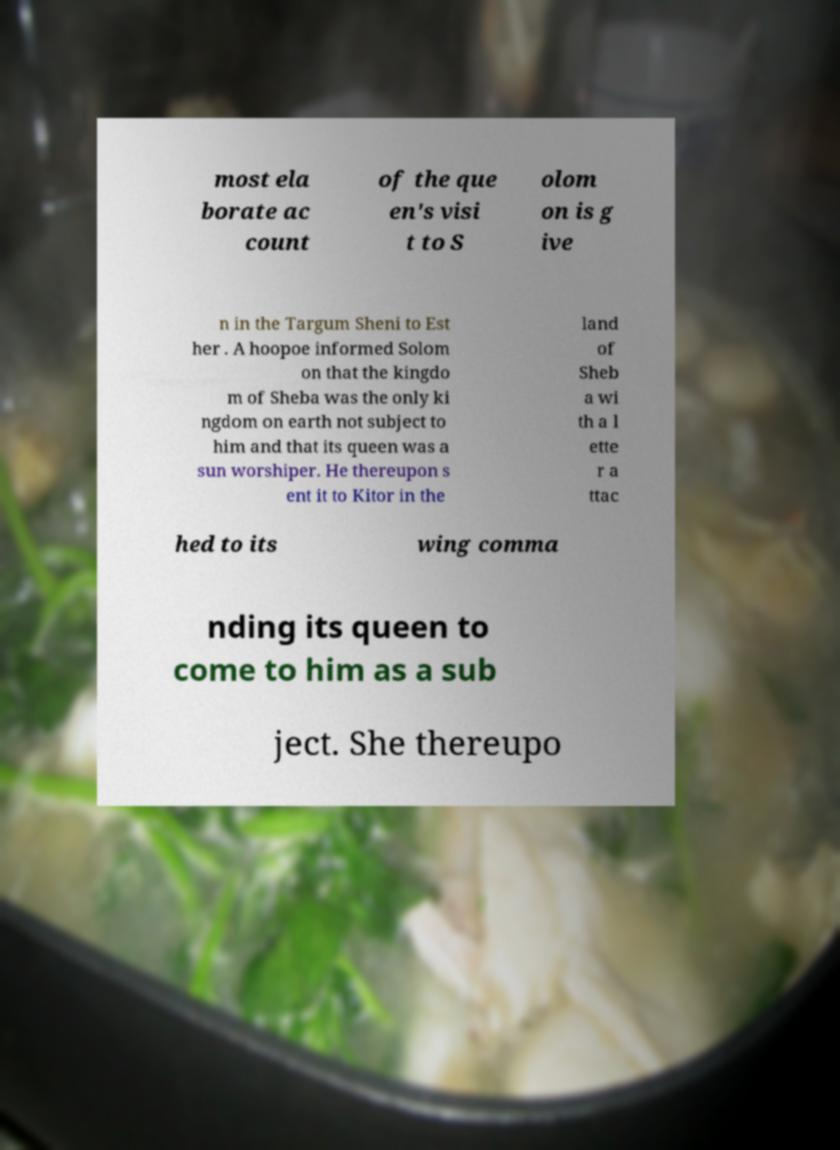Please identify and transcribe the text found in this image. most ela borate ac count of the que en's visi t to S olom on is g ive n in the Targum Sheni to Est her . A hoopoe informed Solom on that the kingdo m of Sheba was the only ki ngdom on earth not subject to him and that its queen was a sun worshiper. He thereupon s ent it to Kitor in the land of Sheb a wi th a l ette r a ttac hed to its wing comma nding its queen to come to him as a sub ject. She thereupo 